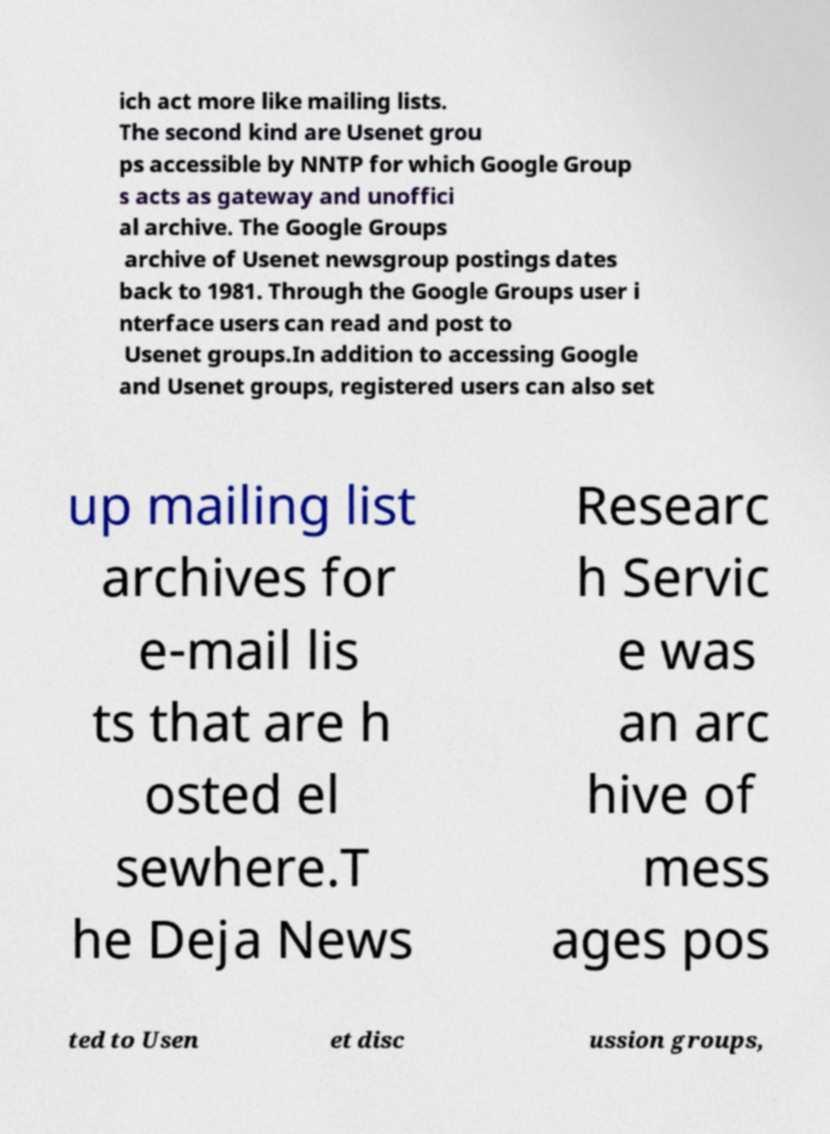Could you assist in decoding the text presented in this image and type it out clearly? ich act more like mailing lists. The second kind are Usenet grou ps accessible by NNTP for which Google Group s acts as gateway and unoffici al archive. The Google Groups archive of Usenet newsgroup postings dates back to 1981. Through the Google Groups user i nterface users can read and post to Usenet groups.In addition to accessing Google and Usenet groups, registered users can also set up mailing list archives for e-mail lis ts that are h osted el sewhere.T he Deja News Researc h Servic e was an arc hive of mess ages pos ted to Usen et disc ussion groups, 